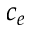Convert formula to latex. <formula><loc_0><loc_0><loc_500><loc_500>c _ { e }</formula> 